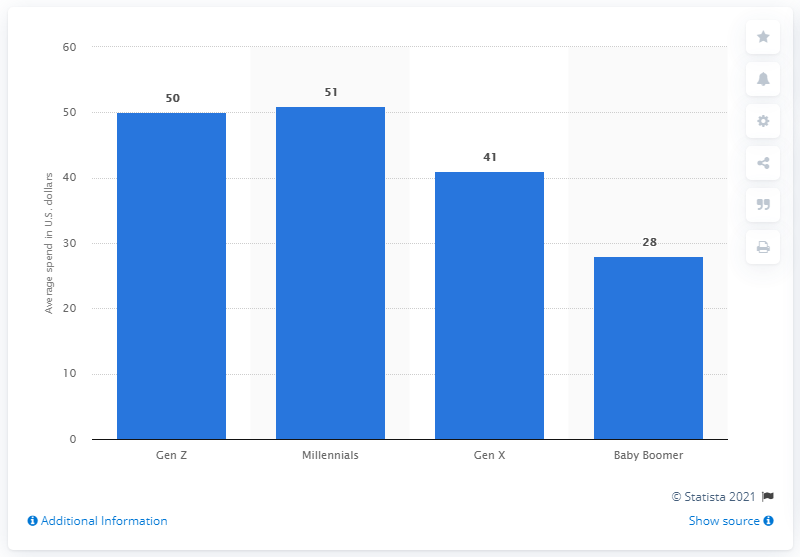Can you specify the source of this data and the year it was published? The data is sourced from Statista, a well-known provider of market and consumer data, and was published in the year 2021, as indicated at the bottom of the image. 